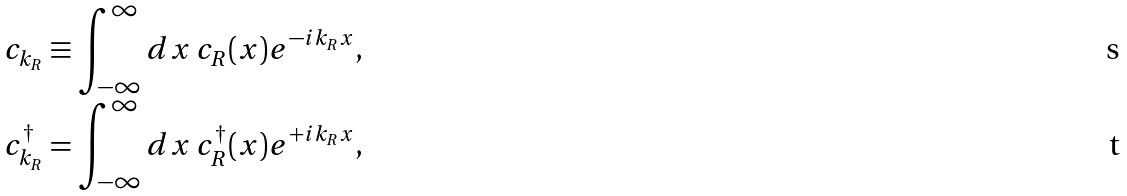Convert formula to latex. <formula><loc_0><loc_0><loc_500><loc_500>c _ { k _ { R } } & \equiv \int _ { - \infty } ^ { \infty } d x \, c _ { R } ( x ) e ^ { - i k _ { R } x } , \\ c _ { k _ { R } } ^ { \dagger } & = \int _ { - \infty } ^ { \infty } d x \, c _ { R } ^ { \dagger } ( x ) e ^ { + i k _ { R } x } ,</formula> 